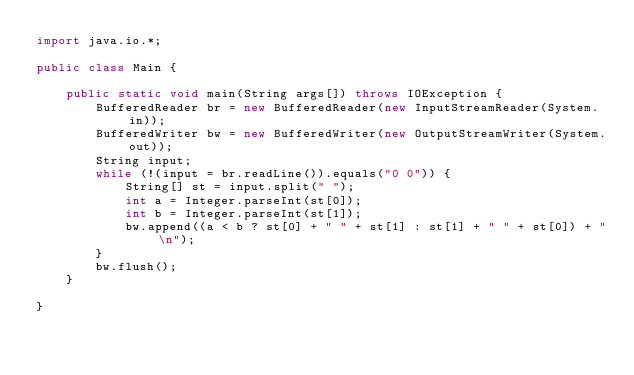Convert code to text. <code><loc_0><loc_0><loc_500><loc_500><_Java_>import java.io.*;

public class Main {

    public static void main(String args[]) throws IOException {
        BufferedReader br = new BufferedReader(new InputStreamReader(System.in));
        BufferedWriter bw = new BufferedWriter(new OutputStreamWriter(System.out));
        String input;
        while (!(input = br.readLine()).equals("0 0")) {
            String[] st = input.split(" ");
            int a = Integer.parseInt(st[0]);
            int b = Integer.parseInt(st[1]);
            bw.append((a < b ? st[0] + " " + st[1] : st[1] + " " + st[0]) + "\n");
        }
        bw.flush();
    }

}

</code> 